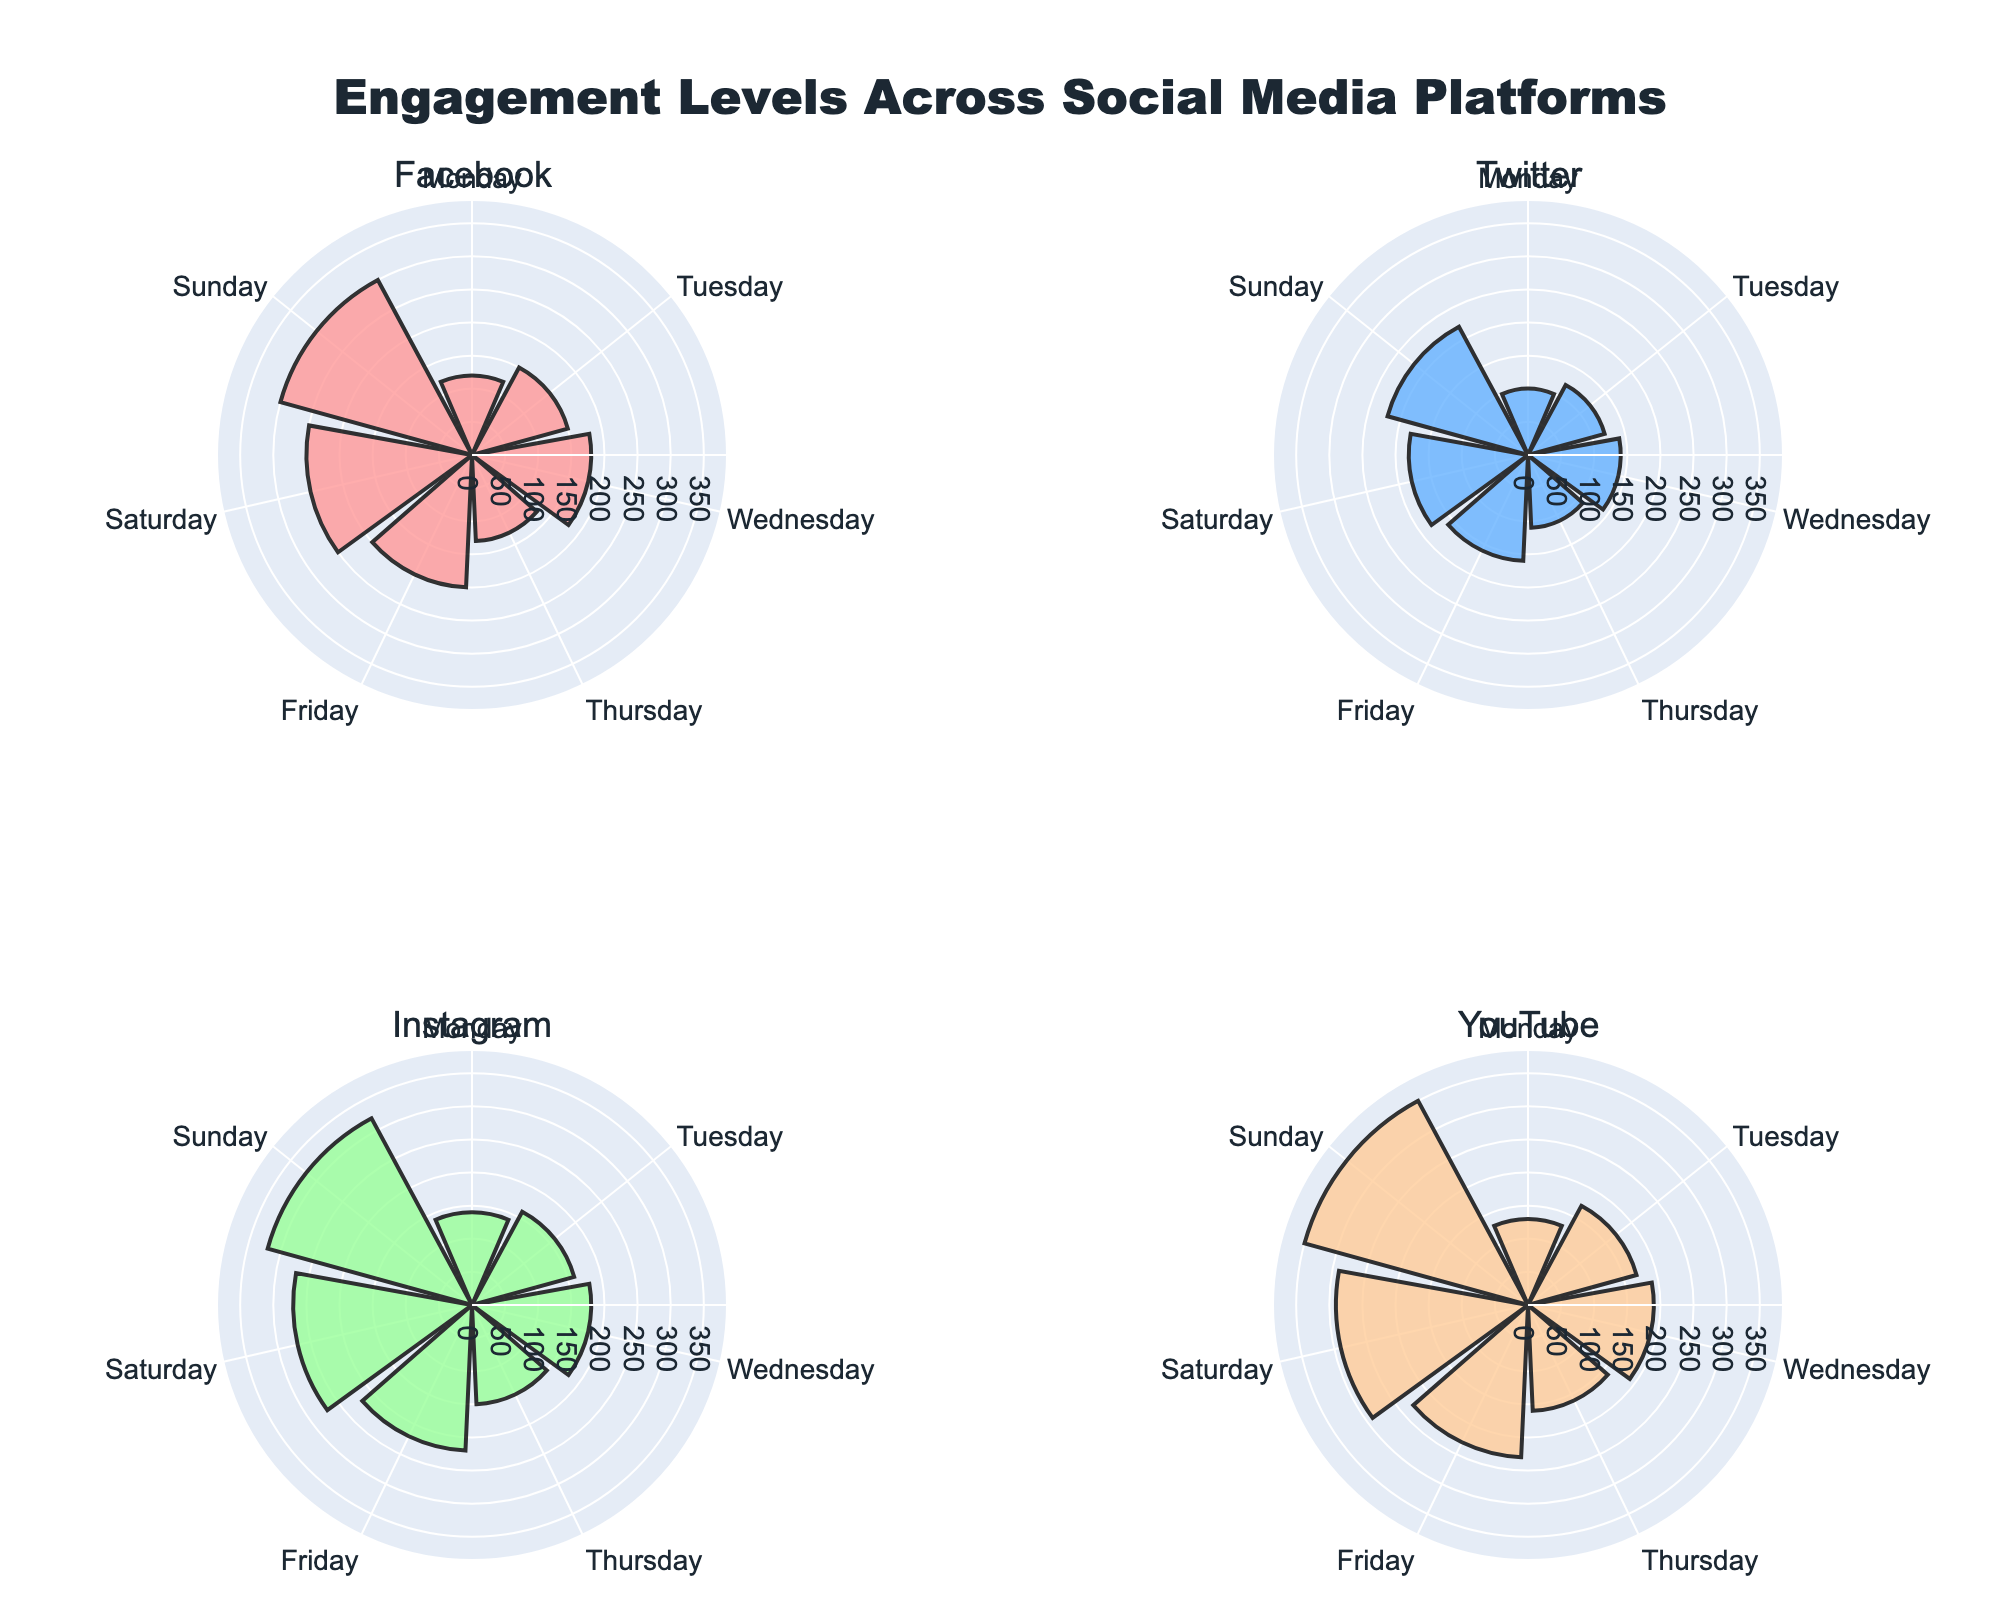What is the highest engagement level for Facebook? The highest engagement level for Facebook can be determined by looking for the longest bar in the rose chart subplot for Facebook.
Answer: 300 Which social media platform has the highest engagement level on Sunday? Compare the longest bars on the Sunday angle for each platform subplot. The platform with the longest bar represents the highest engagement level.
Answer: YouTube What is the average engagement level across all platforms on Saturday? Sum the engagement levels for Saturday across all platforms (250 + 180 + 270 + 290) and then divide by the number of platforms (4).
Answer: 247.5 Which day shows the lowest engagement level for Twitter? Find the shortest bar in the Twitter subplot, which represents the lowest engagement level for each day of the week.
Answer: Monday Compare the engagement levels of Instagram and YouTube on Friday. Which one is higher? Look at the bars corresponding to Friday in both Instagram and YouTube subplots. The longer bar indicates a higher engagement level.
Answer: YouTube On which day does Facebook have its highest engagement level? Identify the longest bar in the Facebook subplot, which represents the highest engagement level for the corresponding day.
Answer: Sunday By how much does YouTube's engagement level on Saturday exceed that on Tuesday? Subtract YouTube's engagement level on Tuesday from that on Saturday (290 - 170).
Answer: 120 Which platform shows the most consistent engagement levels throughout the week? Analyzing the lengths of bars across all days for each platform, the platform with the least variation in bar heights is the most consistent.
Answer: Twitter Is there a day where all platforms have higher engagement levels than the rest of the week? Compare the bar heights for the same day across all subplots. Identify any day where all bar heights are relatively high compared to other days.
Answer: Sunday What is the difference between the engagement level of Facebook and Instagram on Wednesday? Subtract the engagement level of Facebook from Instagram on Wednesday (180 - 180).
Answer: 0 